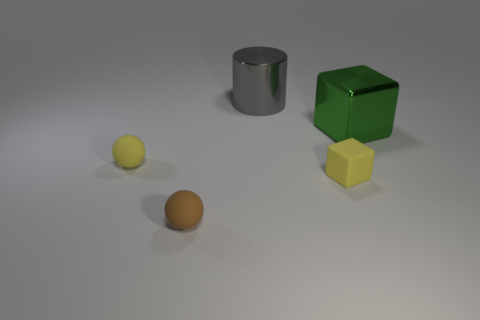Does the yellow ball have the same material as the small brown object?
Your answer should be compact. Yes. What shape is the tiny yellow thing that is left of the gray metallic object that is behind the small yellow thing that is right of the yellow rubber ball?
Offer a very short reply. Sphere. What material is the thing that is both behind the yellow matte block and in front of the green metal object?
Keep it short and to the point. Rubber. There is a large object that is in front of the object behind the green thing that is in front of the gray object; what is its color?
Keep it short and to the point. Green. How many yellow objects are tiny balls or tiny blocks?
Provide a short and direct response. 2. What number of other objects are there of the same size as the matte block?
Keep it short and to the point. 2. How many objects are there?
Give a very brief answer. 5. Is there any other thing that is the same shape as the green metallic thing?
Provide a succinct answer. Yes. Are the big object that is to the left of the large green thing and the small yellow cube that is behind the small brown matte object made of the same material?
Ensure brevity in your answer.  No. What is the gray object made of?
Ensure brevity in your answer.  Metal. 